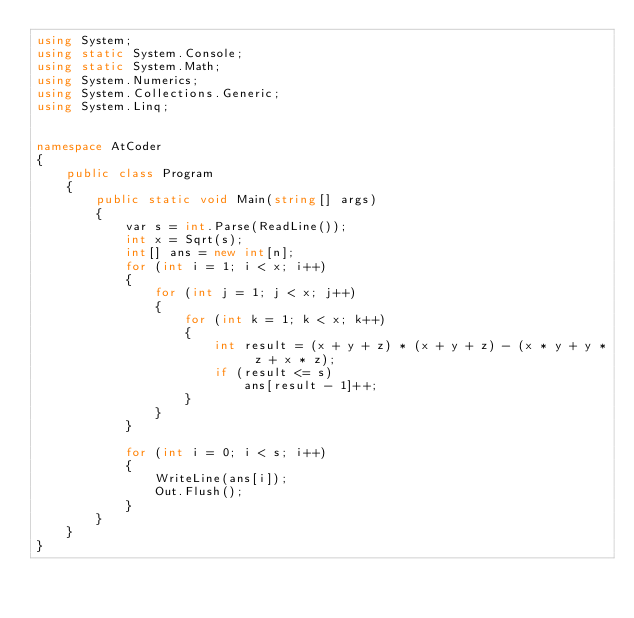<code> <loc_0><loc_0><loc_500><loc_500><_C#_>using System;
using static System.Console;
using static System.Math;
using System.Numerics;
using System.Collections.Generic;
using System.Linq;


namespace AtCoder
{
    public class Program
    {
        public static void Main(string[] args)
        {
            var s = int.Parse(ReadLine());
            int x = Sqrt(s);
            int[] ans = new int[n];
            for (int i = 1; i < x; i++)
            {
                for (int j = 1; j < x; j++)
                {
                    for (int k = 1; k < x; k++)
                    {
                        int result = (x + y + z) * (x + y + z) - (x * y + y * z + x * z);
                        if (result <= s)
                            ans[result - 1]++;
                    }
                }
            }

            for (int i = 0; i < s; i++)
            {
                WriteLine(ans[i]);
                Out.Flush();
            }
        }
    }
}</code> 